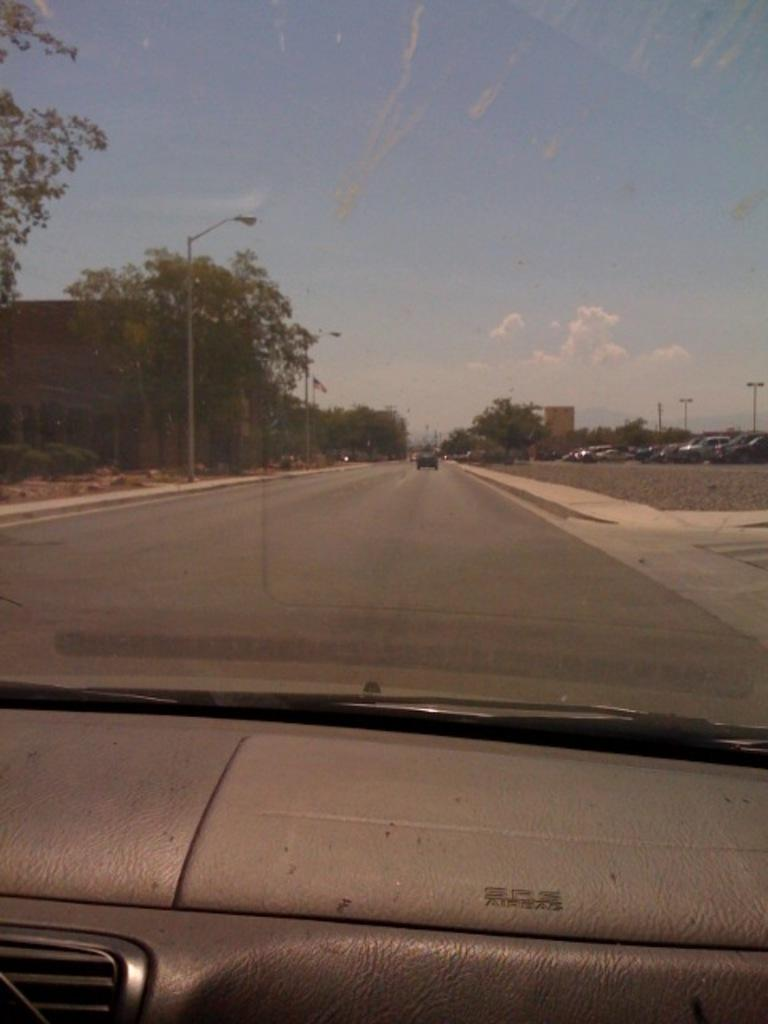What types of objects can be seen in the image? There are vehicles and a glass element visible in the image. What can be seen through the glass element? Poles, trees, a flag, and plants can be seen through the glass element. What is visible in the background of the image? The sky with clouds is visible in the background of the image. What type of scarf is draped over the flag in the image? There is no scarf present in the image; only the flag is visible through the glass. How many tomatoes are growing on the plants visible through the glass? There is no indication of tomatoes growing on the plants visible through the glass in the image. 